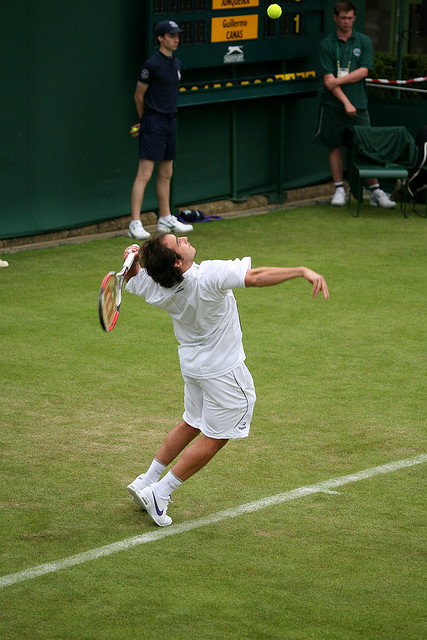<image>Who is your favorite tennis player? It's ambiguous to answer who is my favorite tennis player as I don't have one. Who is your favorite tennis player? I don't know who my favorite tennis player is. I don't have one. 